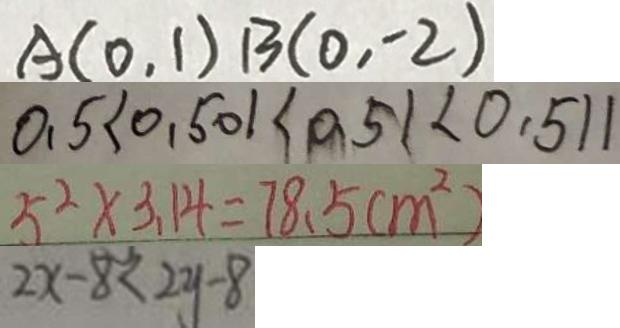<formula> <loc_0><loc_0><loc_500><loc_500>A ( 0 , 1 ) B ( 0 , - 2 ) 
 0 . 5 < 0 . 5 0 1 < 0 . 5 1 < 0 . 5 1 1 
 5 ^ { 2 } \times 3 . 1 4 = 7 8 . 5 ( m ^ { 2 } ) 
 2 x - 8 < 2 y - 8</formula> 